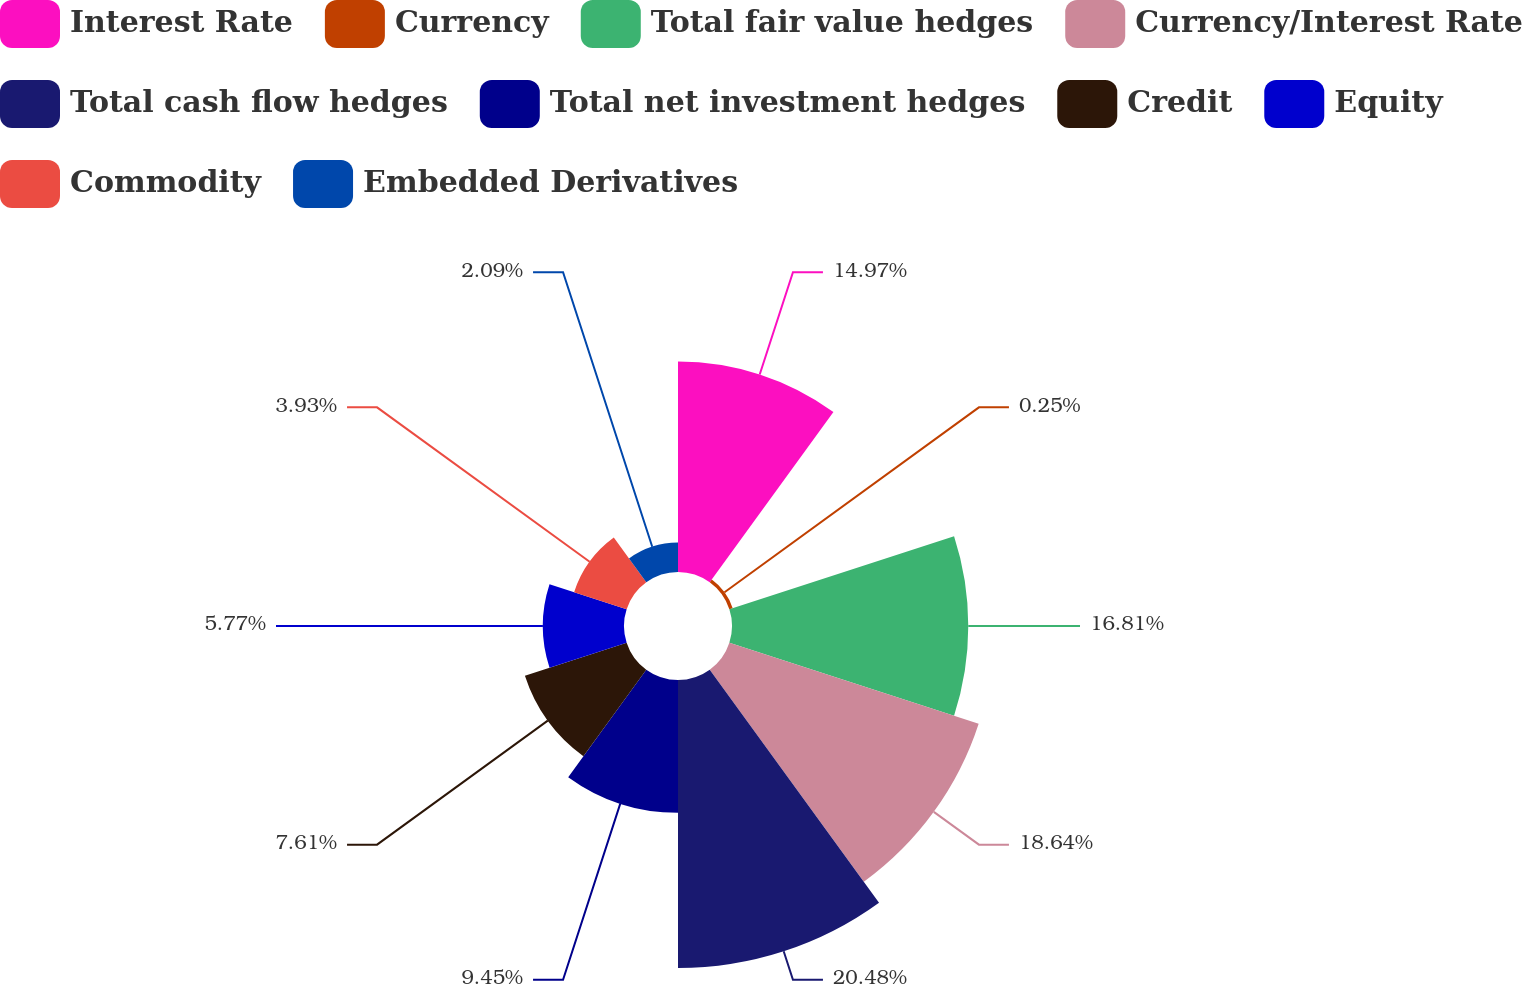Convert chart to OTSL. <chart><loc_0><loc_0><loc_500><loc_500><pie_chart><fcel>Interest Rate<fcel>Currency<fcel>Total fair value hedges<fcel>Currency/Interest Rate<fcel>Total cash flow hedges<fcel>Total net investment hedges<fcel>Credit<fcel>Equity<fcel>Commodity<fcel>Embedded Derivatives<nl><fcel>14.97%<fcel>0.25%<fcel>16.81%<fcel>18.65%<fcel>20.49%<fcel>9.45%<fcel>7.61%<fcel>5.77%<fcel>3.93%<fcel>2.09%<nl></chart> 